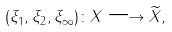Convert formula to latex. <formula><loc_0><loc_0><loc_500><loc_500>( \xi _ { 1 } , \xi _ { 2 } , \xi _ { \infty } ) \colon X \longrightarrow \widetilde { X } ,</formula> 